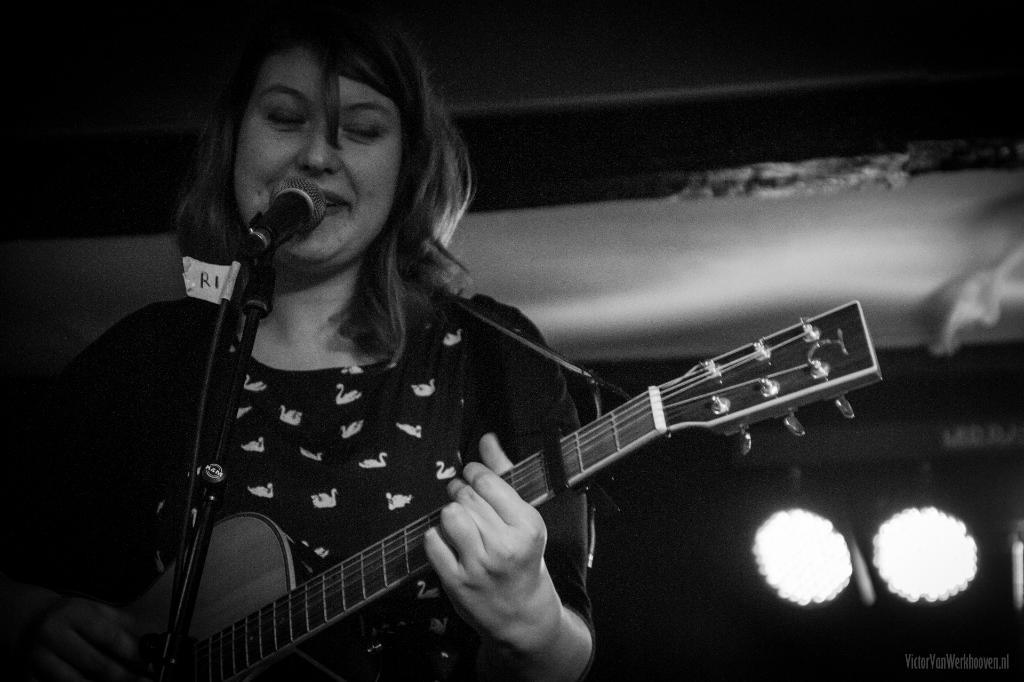What is the color scheme of the image? The image is black and white. Who is the main subject in the image? There is a woman in the image. What is the woman doing in the image? The woman is standing and playing a guitar. What object is in front of the woman? There is a microphone in front of the woman. What can be seen behind the woman? There are lights visible behind the woman. How many friends is the woman's grandmother playing with in the image? There is no mention of a grandmother or friends in the image; it features a woman playing a guitar with a microphone in front of her. What type of drum is the woman playing in the image? There is no drum present in the image; the woman is playing a guitar. 